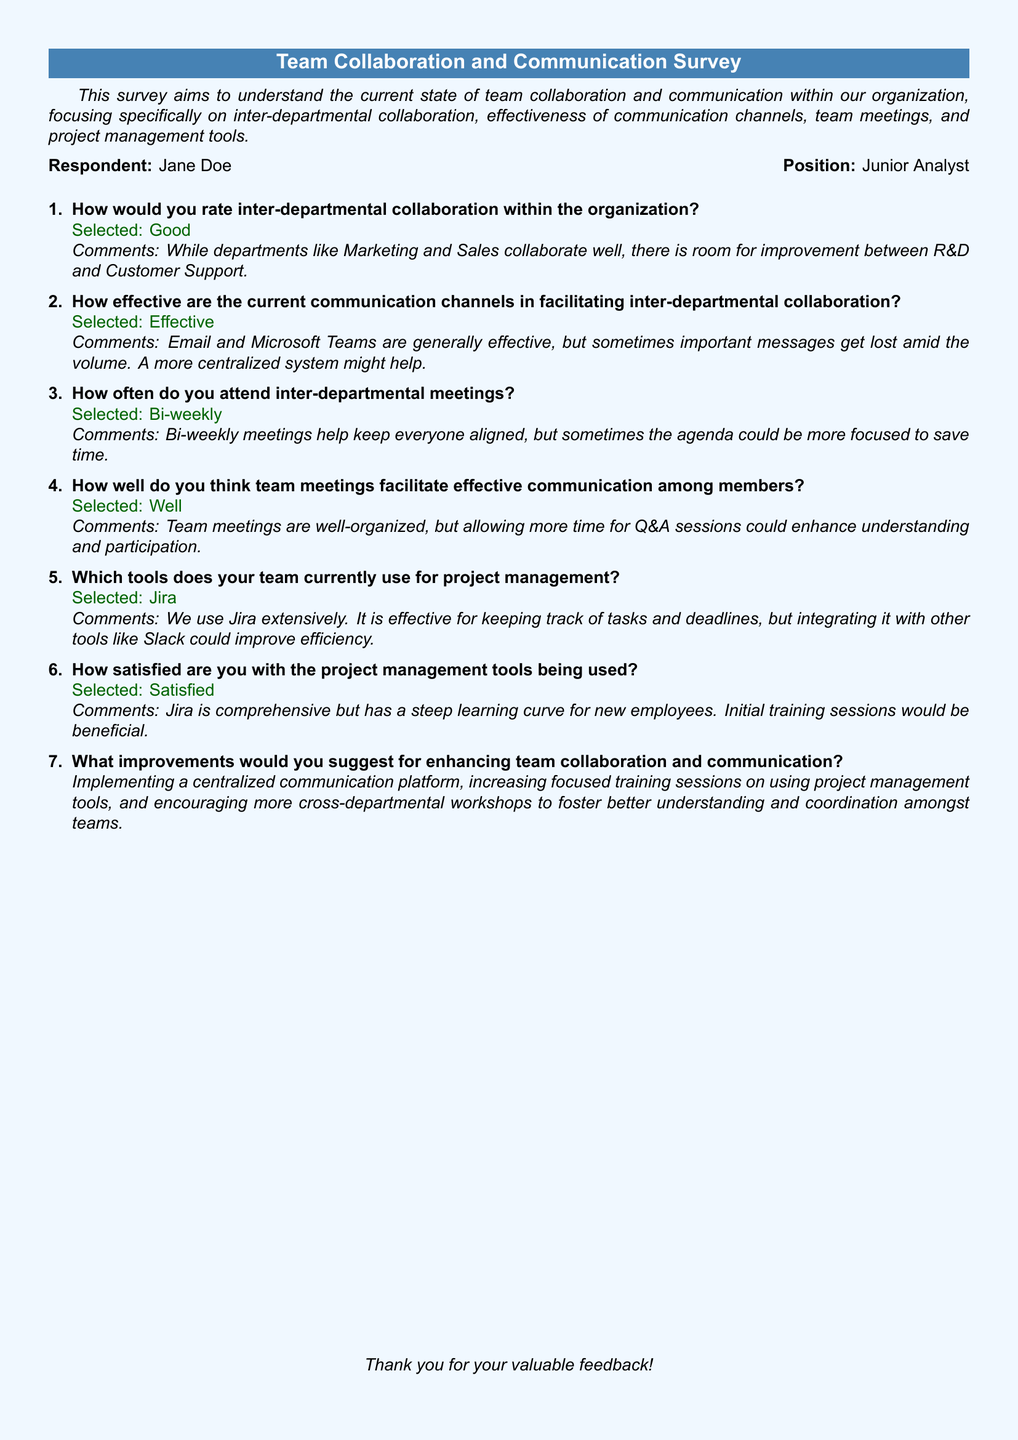What is the name of the respondent? The name of the respondent is listed in the document as part of the introduction section, indicating who filled out the survey.
Answer: Jane Doe What is the selected rating for inter-departmental collaboration? The rating reflects the respondent's perception of collaboration across departments and is stated under inter-departmental collaboration.
Answer: Good How often does the respondent attend inter-departmental meetings? This information reveals the frequency of the meetings the respondent attends and is given in the answer for question three.
Answer: Bi-weekly Which project management tool does the team currently use? This detail identifies the specific tool used by the team for managing projects, as captured in the response to question five.
Answer: Jira What improvement is suggested for enhancing team collaboration? This question seeks to gather insights on specific recommendations made by the respondent for better collaboration, which is summarized in the last question.
Answer: Implementing a centralized communication platform How does the respondent rate their satisfaction with the project management tools? The satisfaction level indicates the respondent's feelings about the tools being used, which is mentioned in the response to question six.
Answer: Satisfied What is the main reason given for the effectiveness of communication channels? The reason for the rating of effectiveness is noted in the comments for question two, indicating the respondent's view on message management.
Answer: Important messages get lost What aspect of team meetings does the respondent suggest could improve understanding? This question targets specific suggestions for enhancing effectiveness in team meetings as expressed in question four.
Answer: More time for Q&A sessions How does the respondent feel about the organization of team meetings? This question gathers the respondent’s evaluation of the structure and format of team meetings as noted in their response to question four.
Answer: Well 